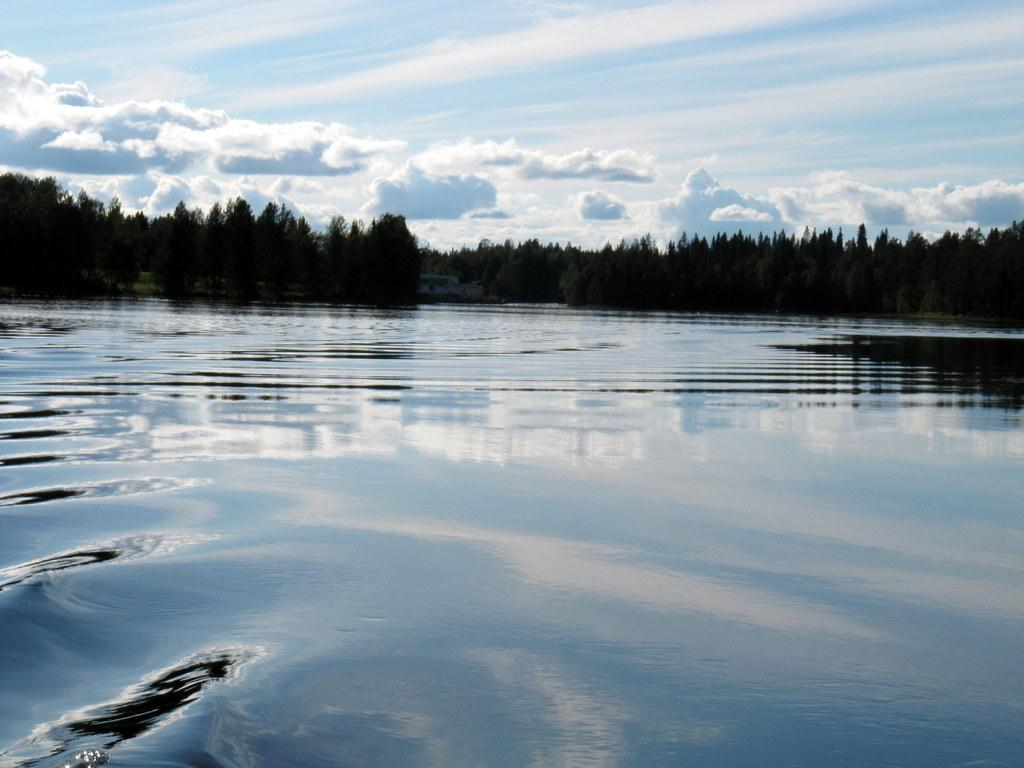What is the primary element in the image? The image consists of water. What can be seen in the middle of the image besides water? There are trees and clouds in the middle of the image. What is visible at the top of the image? There is sky visible at the top of the image. What type of fruit is hanging from the trees in the image? There is no fruit visible in the image; it only shows trees, clouds, and water. Are there any bears visible in the image? There are no bears present in the image. 